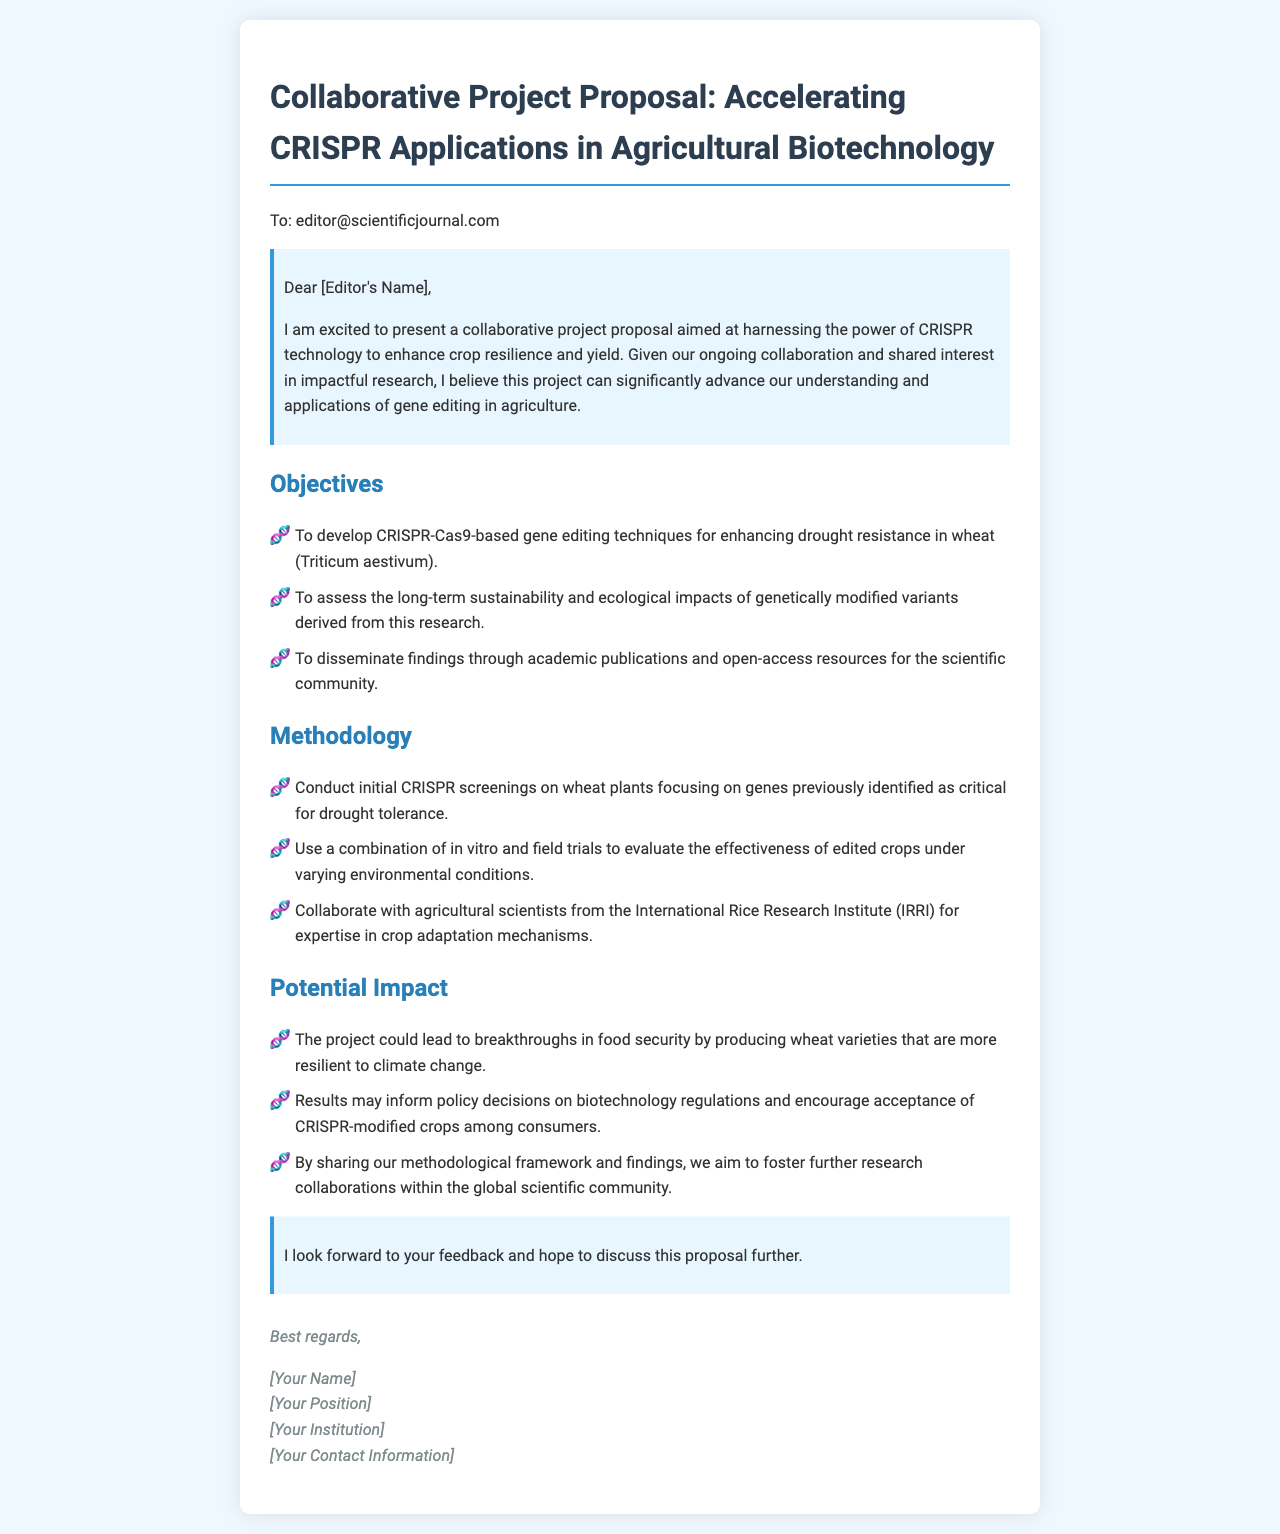What is the title of the project proposal? The title of the project proposal is stated at the beginning of the document.
Answer: Accelerating CRISPR Applications in Agricultural Biotechnology Who is the recipient of the email? The recipient's email address is provided in the document.
Answer: editor@scientificjournal.com What is one of the main objectives of the project? One of the objectives is specifically mentioned in the objectives section of the proposal.
Answer: To develop CRISPR-Cas9-based gene editing techniques for enhancing drought resistance in wheat Which organization is mentioned as a collaborator? The collaborative partner is identified in the methodology section of the document.
Answer: International Rice Research Institute (IRRI) What is the potential impact of this project on food security? The anticipated impact is outlined in the potential impact section of the document.
Answer: Breakthroughs in food security by producing wheat varieties that are more resilient to climate change Who is the author of the email? The author is mentioned towards the end of the document in the signature section.
Answer: [Your Name] What type of research method will be used to evaluate the crops? The methods for evaluation are specified in the methodology section.
Answer: In vitro and field trials What does the author hope to do with the findings? The author's intent for the findings is clearly stated in the potential impact section.
Answer: Foster further research collaborations within the global scientific community 